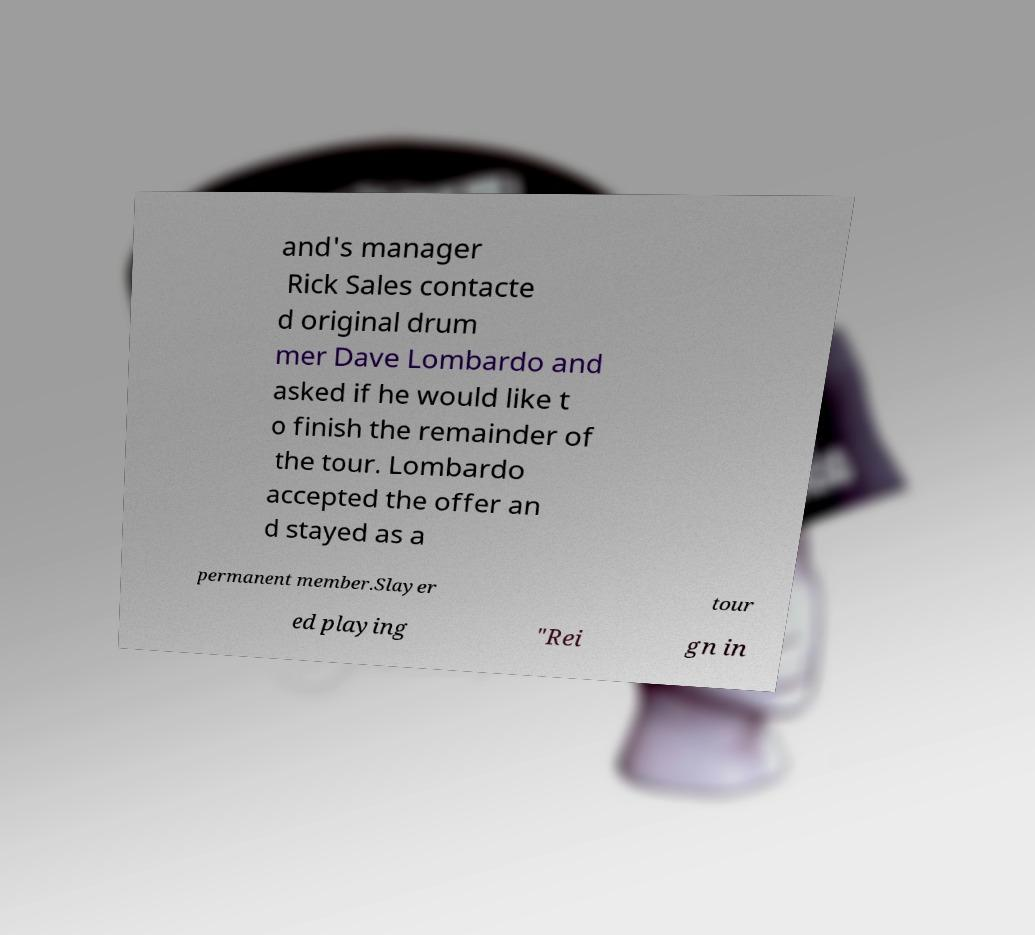For documentation purposes, I need the text within this image transcribed. Could you provide that? and's manager Rick Sales contacte d original drum mer Dave Lombardo and asked if he would like t o finish the remainder of the tour. Lombardo accepted the offer an d stayed as a permanent member.Slayer tour ed playing "Rei gn in 